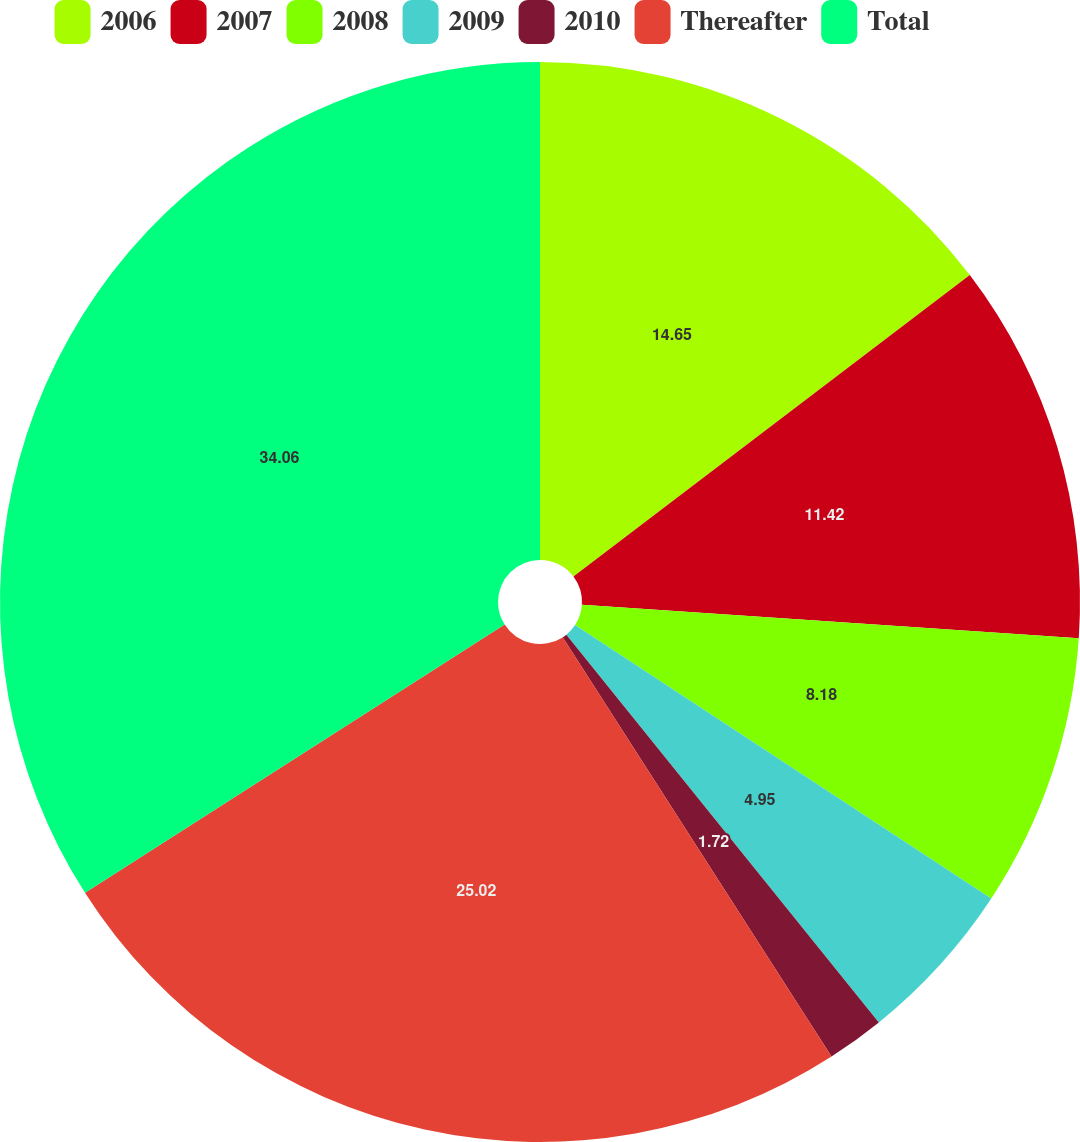Convert chart. <chart><loc_0><loc_0><loc_500><loc_500><pie_chart><fcel>2006<fcel>2007<fcel>2008<fcel>2009<fcel>2010<fcel>Thereafter<fcel>Total<nl><fcel>14.65%<fcel>11.42%<fcel>8.18%<fcel>4.95%<fcel>1.72%<fcel>25.02%<fcel>34.05%<nl></chart> 